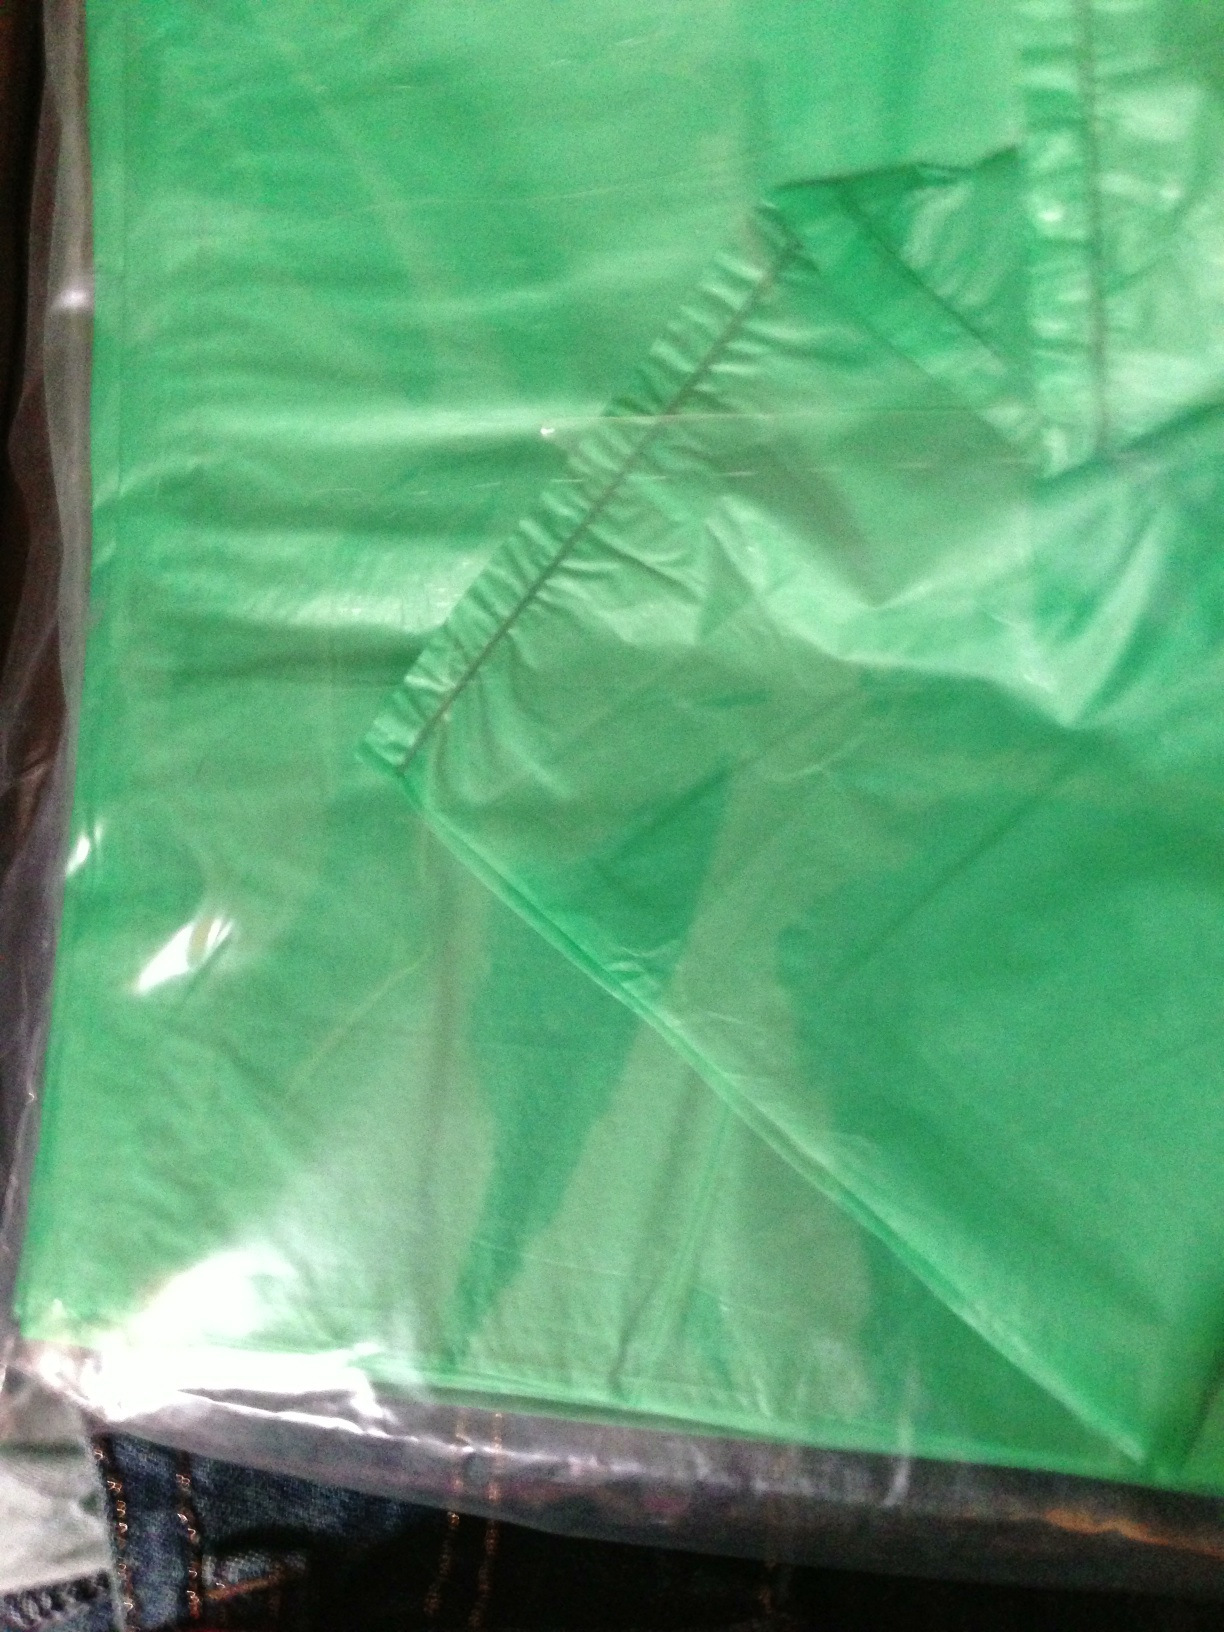What material does the bag appear to be made of? The bag appears to be made of a lightweight, possibly waterproof material with a sheen that could suggest a synthetic fabric like nylon or polyester, commonly used in reusable shopping bags or totes. 